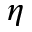<formula> <loc_0><loc_0><loc_500><loc_500>\eta</formula> 